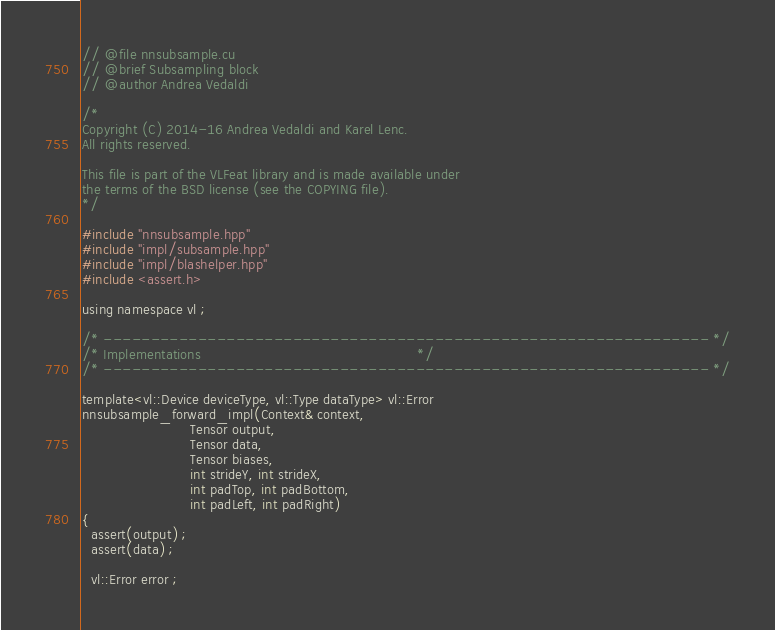<code> <loc_0><loc_0><loc_500><loc_500><_Cuda_>// @file nnsubsample.cu
// @brief Subsampling block
// @author Andrea Vedaldi

/*
Copyright (C) 2014-16 Andrea Vedaldi and Karel Lenc.
All rights reserved.

This file is part of the VLFeat library and is made available under
the terms of the BSD license (see the COPYING file).
*/

#include "nnsubsample.hpp"
#include "impl/subsample.hpp"
#include "impl/blashelper.hpp"
#include <assert.h>

using namespace vl ;

/* ---------------------------------------------------------------- */
/* Implementations                                                  */
/* ---------------------------------------------------------------- */

template<vl::Device deviceType, vl::Type dataType> vl::Error
nnsubsample_forward_impl(Context& context,
                         Tensor output,
                         Tensor data,
                         Tensor biases,
                         int strideY, int strideX,
                         int padTop, int padBottom,
                         int padLeft, int padRight)
{
  assert(output) ;
  assert(data) ;

  vl::Error error ;</code> 